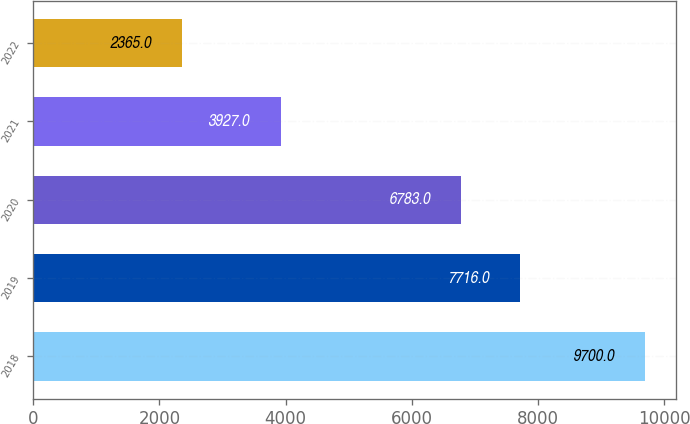Convert chart to OTSL. <chart><loc_0><loc_0><loc_500><loc_500><bar_chart><fcel>2018<fcel>2019<fcel>2020<fcel>2021<fcel>2022<nl><fcel>9700<fcel>7716<fcel>6783<fcel>3927<fcel>2365<nl></chart> 